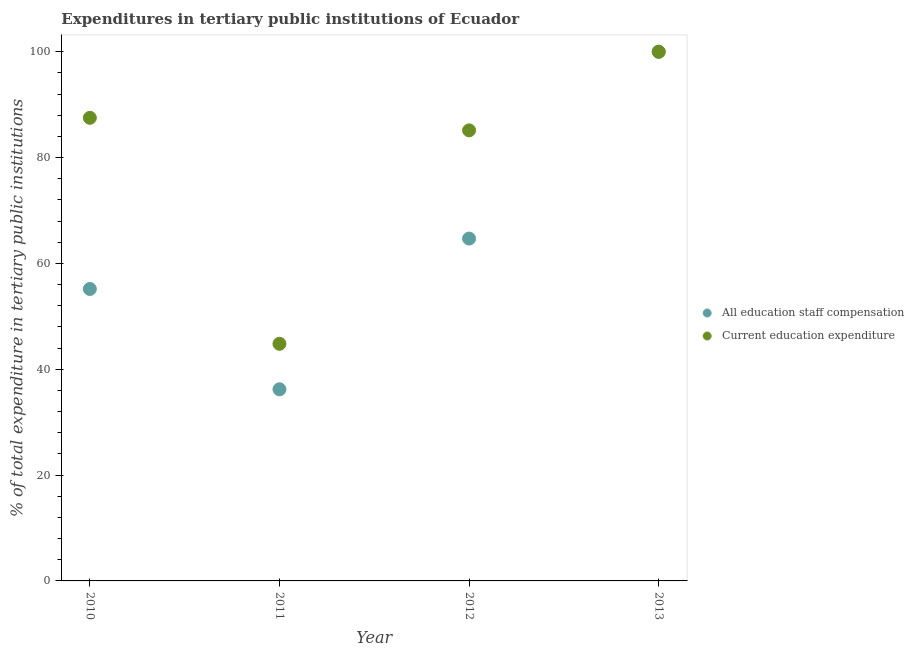How many different coloured dotlines are there?
Your answer should be very brief. 2. Is the number of dotlines equal to the number of legend labels?
Your answer should be very brief. Yes. What is the expenditure in education in 2013?
Your response must be concise. 100. Across all years, what is the maximum expenditure in staff compensation?
Make the answer very short. 100. Across all years, what is the minimum expenditure in education?
Make the answer very short. 44.81. In which year was the expenditure in staff compensation maximum?
Your response must be concise. 2013. What is the total expenditure in education in the graph?
Give a very brief answer. 317.47. What is the difference between the expenditure in staff compensation in 2010 and that in 2012?
Keep it short and to the point. -9.52. What is the difference between the expenditure in staff compensation in 2013 and the expenditure in education in 2012?
Your answer should be very brief. 14.85. What is the average expenditure in education per year?
Keep it short and to the point. 79.37. In the year 2011, what is the difference between the expenditure in education and expenditure in staff compensation?
Your answer should be compact. 8.6. In how many years, is the expenditure in staff compensation greater than 72 %?
Make the answer very short. 1. What is the ratio of the expenditure in education in 2011 to that in 2013?
Provide a short and direct response. 0.45. Is the expenditure in staff compensation in 2012 less than that in 2013?
Your answer should be compact. Yes. Is the difference between the expenditure in education in 2011 and 2013 greater than the difference between the expenditure in staff compensation in 2011 and 2013?
Your answer should be compact. Yes. What is the difference between the highest and the second highest expenditure in staff compensation?
Keep it short and to the point. 35.3. What is the difference between the highest and the lowest expenditure in staff compensation?
Provide a short and direct response. 63.79. In how many years, is the expenditure in education greater than the average expenditure in education taken over all years?
Make the answer very short. 3. Is the sum of the expenditure in staff compensation in 2010 and 2011 greater than the maximum expenditure in education across all years?
Provide a short and direct response. No. Does the expenditure in education monotonically increase over the years?
Your response must be concise. No. Is the expenditure in staff compensation strictly less than the expenditure in education over the years?
Your answer should be compact. No. How many dotlines are there?
Provide a succinct answer. 2. How many years are there in the graph?
Keep it short and to the point. 4. What is the difference between two consecutive major ticks on the Y-axis?
Ensure brevity in your answer.  20. Are the values on the major ticks of Y-axis written in scientific E-notation?
Your answer should be compact. No. Does the graph contain grids?
Ensure brevity in your answer.  No. How many legend labels are there?
Provide a short and direct response. 2. What is the title of the graph?
Ensure brevity in your answer.  Expenditures in tertiary public institutions of Ecuador. What is the label or title of the X-axis?
Ensure brevity in your answer.  Year. What is the label or title of the Y-axis?
Keep it short and to the point. % of total expenditure in tertiary public institutions. What is the % of total expenditure in tertiary public institutions in All education staff compensation in 2010?
Offer a terse response. 55.17. What is the % of total expenditure in tertiary public institutions in Current education expenditure in 2010?
Keep it short and to the point. 87.52. What is the % of total expenditure in tertiary public institutions in All education staff compensation in 2011?
Your answer should be compact. 36.21. What is the % of total expenditure in tertiary public institutions in Current education expenditure in 2011?
Offer a terse response. 44.81. What is the % of total expenditure in tertiary public institutions in All education staff compensation in 2012?
Offer a very short reply. 64.7. What is the % of total expenditure in tertiary public institutions of Current education expenditure in 2012?
Your response must be concise. 85.15. What is the % of total expenditure in tertiary public institutions of Current education expenditure in 2013?
Your response must be concise. 100. Across all years, what is the maximum % of total expenditure in tertiary public institutions in All education staff compensation?
Offer a terse response. 100. Across all years, what is the maximum % of total expenditure in tertiary public institutions of Current education expenditure?
Offer a very short reply. 100. Across all years, what is the minimum % of total expenditure in tertiary public institutions of All education staff compensation?
Offer a terse response. 36.21. Across all years, what is the minimum % of total expenditure in tertiary public institutions of Current education expenditure?
Provide a succinct answer. 44.81. What is the total % of total expenditure in tertiary public institutions in All education staff compensation in the graph?
Offer a very short reply. 256.08. What is the total % of total expenditure in tertiary public institutions of Current education expenditure in the graph?
Offer a terse response. 317.47. What is the difference between the % of total expenditure in tertiary public institutions in All education staff compensation in 2010 and that in 2011?
Offer a very short reply. 18.96. What is the difference between the % of total expenditure in tertiary public institutions in Current education expenditure in 2010 and that in 2011?
Provide a short and direct response. 42.71. What is the difference between the % of total expenditure in tertiary public institutions of All education staff compensation in 2010 and that in 2012?
Offer a terse response. -9.52. What is the difference between the % of total expenditure in tertiary public institutions of Current education expenditure in 2010 and that in 2012?
Make the answer very short. 2.37. What is the difference between the % of total expenditure in tertiary public institutions in All education staff compensation in 2010 and that in 2013?
Your response must be concise. -44.83. What is the difference between the % of total expenditure in tertiary public institutions of Current education expenditure in 2010 and that in 2013?
Keep it short and to the point. -12.48. What is the difference between the % of total expenditure in tertiary public institutions of All education staff compensation in 2011 and that in 2012?
Make the answer very short. -28.48. What is the difference between the % of total expenditure in tertiary public institutions of Current education expenditure in 2011 and that in 2012?
Your answer should be compact. -40.34. What is the difference between the % of total expenditure in tertiary public institutions of All education staff compensation in 2011 and that in 2013?
Provide a succinct answer. -63.79. What is the difference between the % of total expenditure in tertiary public institutions of Current education expenditure in 2011 and that in 2013?
Make the answer very short. -55.19. What is the difference between the % of total expenditure in tertiary public institutions in All education staff compensation in 2012 and that in 2013?
Provide a short and direct response. -35.3. What is the difference between the % of total expenditure in tertiary public institutions in Current education expenditure in 2012 and that in 2013?
Provide a succinct answer. -14.85. What is the difference between the % of total expenditure in tertiary public institutions of All education staff compensation in 2010 and the % of total expenditure in tertiary public institutions of Current education expenditure in 2011?
Your answer should be very brief. 10.36. What is the difference between the % of total expenditure in tertiary public institutions in All education staff compensation in 2010 and the % of total expenditure in tertiary public institutions in Current education expenditure in 2012?
Provide a succinct answer. -29.97. What is the difference between the % of total expenditure in tertiary public institutions of All education staff compensation in 2010 and the % of total expenditure in tertiary public institutions of Current education expenditure in 2013?
Provide a succinct answer. -44.83. What is the difference between the % of total expenditure in tertiary public institutions of All education staff compensation in 2011 and the % of total expenditure in tertiary public institutions of Current education expenditure in 2012?
Offer a very short reply. -48.93. What is the difference between the % of total expenditure in tertiary public institutions in All education staff compensation in 2011 and the % of total expenditure in tertiary public institutions in Current education expenditure in 2013?
Your answer should be very brief. -63.79. What is the difference between the % of total expenditure in tertiary public institutions in All education staff compensation in 2012 and the % of total expenditure in tertiary public institutions in Current education expenditure in 2013?
Offer a very short reply. -35.3. What is the average % of total expenditure in tertiary public institutions in All education staff compensation per year?
Offer a terse response. 64.02. What is the average % of total expenditure in tertiary public institutions in Current education expenditure per year?
Offer a very short reply. 79.37. In the year 2010, what is the difference between the % of total expenditure in tertiary public institutions in All education staff compensation and % of total expenditure in tertiary public institutions in Current education expenditure?
Offer a terse response. -32.34. In the year 2011, what is the difference between the % of total expenditure in tertiary public institutions of All education staff compensation and % of total expenditure in tertiary public institutions of Current education expenditure?
Give a very brief answer. -8.6. In the year 2012, what is the difference between the % of total expenditure in tertiary public institutions in All education staff compensation and % of total expenditure in tertiary public institutions in Current education expenditure?
Your answer should be compact. -20.45. In the year 2013, what is the difference between the % of total expenditure in tertiary public institutions of All education staff compensation and % of total expenditure in tertiary public institutions of Current education expenditure?
Keep it short and to the point. 0. What is the ratio of the % of total expenditure in tertiary public institutions of All education staff compensation in 2010 to that in 2011?
Give a very brief answer. 1.52. What is the ratio of the % of total expenditure in tertiary public institutions of Current education expenditure in 2010 to that in 2011?
Give a very brief answer. 1.95. What is the ratio of the % of total expenditure in tertiary public institutions of All education staff compensation in 2010 to that in 2012?
Your answer should be compact. 0.85. What is the ratio of the % of total expenditure in tertiary public institutions of Current education expenditure in 2010 to that in 2012?
Offer a very short reply. 1.03. What is the ratio of the % of total expenditure in tertiary public institutions of All education staff compensation in 2010 to that in 2013?
Make the answer very short. 0.55. What is the ratio of the % of total expenditure in tertiary public institutions of Current education expenditure in 2010 to that in 2013?
Offer a terse response. 0.88. What is the ratio of the % of total expenditure in tertiary public institutions of All education staff compensation in 2011 to that in 2012?
Your answer should be very brief. 0.56. What is the ratio of the % of total expenditure in tertiary public institutions in Current education expenditure in 2011 to that in 2012?
Keep it short and to the point. 0.53. What is the ratio of the % of total expenditure in tertiary public institutions in All education staff compensation in 2011 to that in 2013?
Offer a terse response. 0.36. What is the ratio of the % of total expenditure in tertiary public institutions of Current education expenditure in 2011 to that in 2013?
Ensure brevity in your answer.  0.45. What is the ratio of the % of total expenditure in tertiary public institutions of All education staff compensation in 2012 to that in 2013?
Give a very brief answer. 0.65. What is the ratio of the % of total expenditure in tertiary public institutions in Current education expenditure in 2012 to that in 2013?
Offer a terse response. 0.85. What is the difference between the highest and the second highest % of total expenditure in tertiary public institutions of All education staff compensation?
Offer a terse response. 35.3. What is the difference between the highest and the second highest % of total expenditure in tertiary public institutions in Current education expenditure?
Keep it short and to the point. 12.48. What is the difference between the highest and the lowest % of total expenditure in tertiary public institutions in All education staff compensation?
Your answer should be compact. 63.79. What is the difference between the highest and the lowest % of total expenditure in tertiary public institutions in Current education expenditure?
Give a very brief answer. 55.19. 